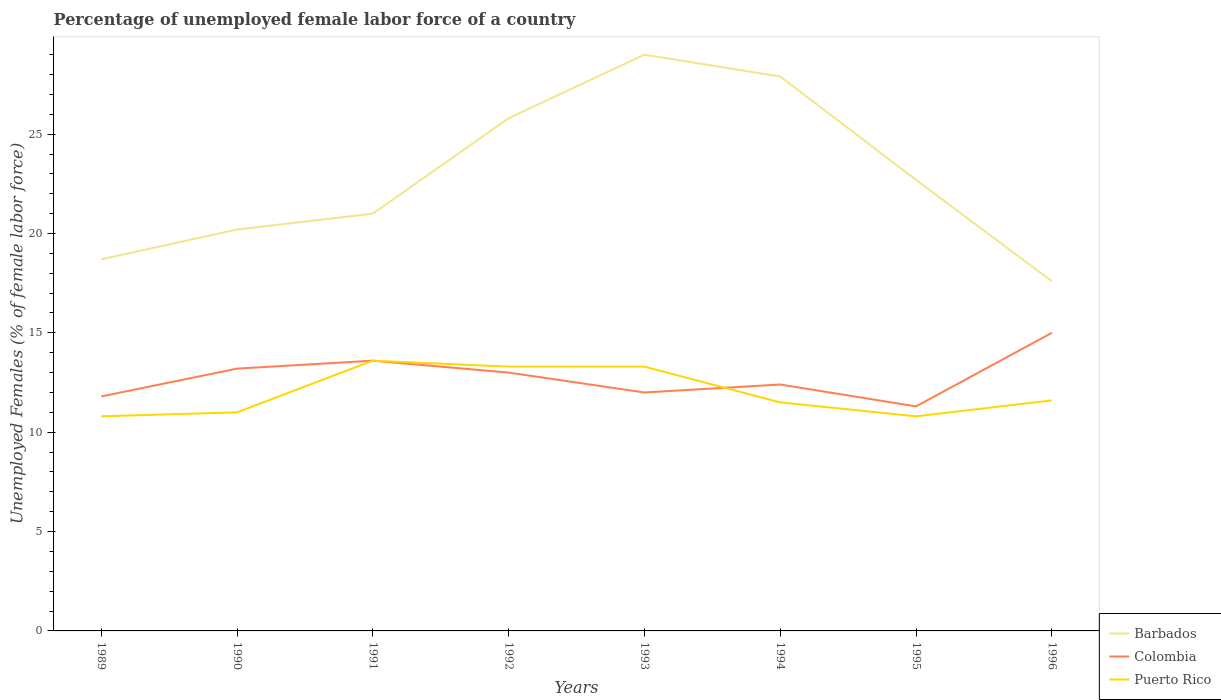How many different coloured lines are there?
Make the answer very short. 3. Is the number of lines equal to the number of legend labels?
Give a very brief answer. Yes. Across all years, what is the maximum percentage of unemployed female labor force in Colombia?
Ensure brevity in your answer.  11.3. In which year was the percentage of unemployed female labor force in Puerto Rico maximum?
Make the answer very short. 1989. What is the total percentage of unemployed female labor force in Colombia in the graph?
Offer a terse response. 0.2. What is the difference between the highest and the second highest percentage of unemployed female labor force in Barbados?
Offer a terse response. 11.4. What is the difference between the highest and the lowest percentage of unemployed female labor force in Colombia?
Offer a very short reply. 4. Is the percentage of unemployed female labor force in Colombia strictly greater than the percentage of unemployed female labor force in Puerto Rico over the years?
Offer a terse response. No. How many lines are there?
Make the answer very short. 3. How many years are there in the graph?
Offer a very short reply. 8. Are the values on the major ticks of Y-axis written in scientific E-notation?
Make the answer very short. No. Does the graph contain any zero values?
Your answer should be compact. No. Does the graph contain grids?
Your answer should be very brief. No. Where does the legend appear in the graph?
Provide a succinct answer. Bottom right. How many legend labels are there?
Ensure brevity in your answer.  3. What is the title of the graph?
Your response must be concise. Percentage of unemployed female labor force of a country. Does "St. Kitts and Nevis" appear as one of the legend labels in the graph?
Offer a terse response. No. What is the label or title of the X-axis?
Offer a terse response. Years. What is the label or title of the Y-axis?
Keep it short and to the point. Unemployed Females (% of female labor force). What is the Unemployed Females (% of female labor force) in Barbados in 1989?
Offer a terse response. 18.7. What is the Unemployed Females (% of female labor force) of Colombia in 1989?
Your answer should be very brief. 11.8. What is the Unemployed Females (% of female labor force) in Puerto Rico in 1989?
Your response must be concise. 10.8. What is the Unemployed Females (% of female labor force) of Barbados in 1990?
Offer a very short reply. 20.2. What is the Unemployed Females (% of female labor force) in Colombia in 1990?
Offer a very short reply. 13.2. What is the Unemployed Females (% of female labor force) of Puerto Rico in 1990?
Your answer should be compact. 11. What is the Unemployed Females (% of female labor force) of Colombia in 1991?
Make the answer very short. 13.6. What is the Unemployed Females (% of female labor force) of Puerto Rico in 1991?
Your answer should be compact. 13.6. What is the Unemployed Females (% of female labor force) in Barbados in 1992?
Offer a terse response. 25.8. What is the Unemployed Females (% of female labor force) in Puerto Rico in 1992?
Provide a succinct answer. 13.3. What is the Unemployed Females (% of female labor force) in Barbados in 1993?
Give a very brief answer. 29. What is the Unemployed Females (% of female labor force) in Puerto Rico in 1993?
Offer a terse response. 13.3. What is the Unemployed Females (% of female labor force) of Barbados in 1994?
Offer a terse response. 27.9. What is the Unemployed Females (% of female labor force) of Colombia in 1994?
Your answer should be compact. 12.4. What is the Unemployed Females (% of female labor force) in Barbados in 1995?
Make the answer very short. 22.7. What is the Unemployed Females (% of female labor force) in Colombia in 1995?
Provide a short and direct response. 11.3. What is the Unemployed Females (% of female labor force) of Puerto Rico in 1995?
Your answer should be compact. 10.8. What is the Unemployed Females (% of female labor force) of Barbados in 1996?
Your answer should be very brief. 17.6. What is the Unemployed Females (% of female labor force) in Colombia in 1996?
Give a very brief answer. 15. What is the Unemployed Females (% of female labor force) of Puerto Rico in 1996?
Provide a succinct answer. 11.6. Across all years, what is the maximum Unemployed Females (% of female labor force) in Colombia?
Offer a very short reply. 15. Across all years, what is the maximum Unemployed Females (% of female labor force) of Puerto Rico?
Keep it short and to the point. 13.6. Across all years, what is the minimum Unemployed Females (% of female labor force) of Barbados?
Provide a succinct answer. 17.6. Across all years, what is the minimum Unemployed Females (% of female labor force) of Colombia?
Make the answer very short. 11.3. Across all years, what is the minimum Unemployed Females (% of female labor force) of Puerto Rico?
Keep it short and to the point. 10.8. What is the total Unemployed Females (% of female labor force) of Barbados in the graph?
Make the answer very short. 182.9. What is the total Unemployed Females (% of female labor force) in Colombia in the graph?
Give a very brief answer. 102.3. What is the total Unemployed Females (% of female labor force) of Puerto Rico in the graph?
Keep it short and to the point. 95.9. What is the difference between the Unemployed Females (% of female labor force) of Colombia in 1989 and that in 1991?
Ensure brevity in your answer.  -1.8. What is the difference between the Unemployed Females (% of female labor force) in Colombia in 1989 and that in 1992?
Ensure brevity in your answer.  -1.2. What is the difference between the Unemployed Females (% of female labor force) of Puerto Rico in 1989 and that in 1992?
Provide a succinct answer. -2.5. What is the difference between the Unemployed Females (% of female labor force) of Puerto Rico in 1989 and that in 1993?
Make the answer very short. -2.5. What is the difference between the Unemployed Females (% of female labor force) of Puerto Rico in 1989 and that in 1994?
Provide a short and direct response. -0.7. What is the difference between the Unemployed Females (% of female labor force) of Barbados in 1989 and that in 1995?
Make the answer very short. -4. What is the difference between the Unemployed Females (% of female labor force) in Puerto Rico in 1989 and that in 1995?
Provide a short and direct response. 0. What is the difference between the Unemployed Females (% of female labor force) in Colombia in 1989 and that in 1996?
Offer a terse response. -3.2. What is the difference between the Unemployed Females (% of female labor force) of Puerto Rico in 1989 and that in 1996?
Ensure brevity in your answer.  -0.8. What is the difference between the Unemployed Females (% of female labor force) in Barbados in 1990 and that in 1991?
Give a very brief answer. -0.8. What is the difference between the Unemployed Females (% of female labor force) of Colombia in 1990 and that in 1991?
Make the answer very short. -0.4. What is the difference between the Unemployed Females (% of female labor force) of Puerto Rico in 1990 and that in 1991?
Your answer should be very brief. -2.6. What is the difference between the Unemployed Females (% of female labor force) of Colombia in 1990 and that in 1992?
Your answer should be compact. 0.2. What is the difference between the Unemployed Females (% of female labor force) of Barbados in 1990 and that in 1993?
Your answer should be very brief. -8.8. What is the difference between the Unemployed Females (% of female labor force) in Puerto Rico in 1990 and that in 1993?
Your response must be concise. -2.3. What is the difference between the Unemployed Females (% of female labor force) in Barbados in 1990 and that in 1994?
Keep it short and to the point. -7.7. What is the difference between the Unemployed Females (% of female labor force) of Colombia in 1990 and that in 1994?
Your response must be concise. 0.8. What is the difference between the Unemployed Females (% of female labor force) of Puerto Rico in 1990 and that in 1994?
Offer a very short reply. -0.5. What is the difference between the Unemployed Females (% of female labor force) of Barbados in 1990 and that in 1995?
Provide a succinct answer. -2.5. What is the difference between the Unemployed Females (% of female labor force) in Colombia in 1990 and that in 1995?
Your response must be concise. 1.9. What is the difference between the Unemployed Females (% of female labor force) in Barbados in 1991 and that in 1992?
Give a very brief answer. -4.8. What is the difference between the Unemployed Females (% of female labor force) in Barbados in 1991 and that in 1993?
Your answer should be compact. -8. What is the difference between the Unemployed Females (% of female labor force) of Colombia in 1991 and that in 1993?
Provide a succinct answer. 1.6. What is the difference between the Unemployed Females (% of female labor force) in Barbados in 1991 and that in 1994?
Keep it short and to the point. -6.9. What is the difference between the Unemployed Females (% of female labor force) of Puerto Rico in 1991 and that in 1994?
Offer a terse response. 2.1. What is the difference between the Unemployed Females (% of female labor force) in Barbados in 1991 and that in 1995?
Offer a very short reply. -1.7. What is the difference between the Unemployed Females (% of female labor force) in Barbados in 1991 and that in 1996?
Offer a terse response. 3.4. What is the difference between the Unemployed Females (% of female labor force) in Colombia in 1991 and that in 1996?
Your response must be concise. -1.4. What is the difference between the Unemployed Females (% of female labor force) of Puerto Rico in 1991 and that in 1996?
Your answer should be compact. 2. What is the difference between the Unemployed Females (% of female labor force) in Colombia in 1992 and that in 1993?
Offer a very short reply. 1. What is the difference between the Unemployed Females (% of female labor force) of Puerto Rico in 1992 and that in 1993?
Make the answer very short. 0. What is the difference between the Unemployed Females (% of female labor force) in Barbados in 1992 and that in 1994?
Your response must be concise. -2.1. What is the difference between the Unemployed Females (% of female labor force) of Puerto Rico in 1992 and that in 1994?
Provide a succinct answer. 1.8. What is the difference between the Unemployed Females (% of female labor force) of Barbados in 1992 and that in 1995?
Keep it short and to the point. 3.1. What is the difference between the Unemployed Females (% of female labor force) of Colombia in 1992 and that in 1995?
Provide a short and direct response. 1.7. What is the difference between the Unemployed Females (% of female labor force) in Colombia in 1992 and that in 1996?
Your response must be concise. -2. What is the difference between the Unemployed Females (% of female labor force) in Barbados in 1993 and that in 1994?
Your response must be concise. 1.1. What is the difference between the Unemployed Females (% of female labor force) in Colombia in 1993 and that in 1994?
Your answer should be compact. -0.4. What is the difference between the Unemployed Females (% of female labor force) in Barbados in 1993 and that in 1995?
Keep it short and to the point. 6.3. What is the difference between the Unemployed Females (% of female labor force) in Colombia in 1993 and that in 1995?
Ensure brevity in your answer.  0.7. What is the difference between the Unemployed Females (% of female labor force) of Barbados in 1993 and that in 1996?
Offer a terse response. 11.4. What is the difference between the Unemployed Females (% of female labor force) in Puerto Rico in 1993 and that in 1996?
Make the answer very short. 1.7. What is the difference between the Unemployed Females (% of female labor force) in Barbados in 1994 and that in 1995?
Ensure brevity in your answer.  5.2. What is the difference between the Unemployed Females (% of female labor force) in Puerto Rico in 1994 and that in 1995?
Your answer should be very brief. 0.7. What is the difference between the Unemployed Females (% of female labor force) in Barbados in 1994 and that in 1996?
Your answer should be very brief. 10.3. What is the difference between the Unemployed Females (% of female labor force) in Colombia in 1994 and that in 1996?
Keep it short and to the point. -2.6. What is the difference between the Unemployed Females (% of female labor force) in Puerto Rico in 1994 and that in 1996?
Ensure brevity in your answer.  -0.1. What is the difference between the Unemployed Females (% of female labor force) in Colombia in 1995 and that in 1996?
Provide a short and direct response. -3.7. What is the difference between the Unemployed Females (% of female labor force) in Colombia in 1989 and the Unemployed Females (% of female labor force) in Puerto Rico in 1990?
Ensure brevity in your answer.  0.8. What is the difference between the Unemployed Females (% of female labor force) in Barbados in 1989 and the Unemployed Females (% of female labor force) in Puerto Rico in 1991?
Give a very brief answer. 5.1. What is the difference between the Unemployed Females (% of female labor force) in Colombia in 1989 and the Unemployed Females (% of female labor force) in Puerto Rico in 1991?
Provide a succinct answer. -1.8. What is the difference between the Unemployed Females (% of female labor force) of Barbados in 1989 and the Unemployed Females (% of female labor force) of Colombia in 1992?
Your answer should be compact. 5.7. What is the difference between the Unemployed Females (% of female labor force) in Barbados in 1989 and the Unemployed Females (% of female labor force) in Puerto Rico in 1992?
Offer a very short reply. 5.4. What is the difference between the Unemployed Females (% of female labor force) in Barbados in 1989 and the Unemployed Females (% of female labor force) in Colombia in 1994?
Your answer should be very brief. 6.3. What is the difference between the Unemployed Females (% of female labor force) of Barbados in 1989 and the Unemployed Females (% of female labor force) of Puerto Rico in 1994?
Offer a terse response. 7.2. What is the difference between the Unemployed Females (% of female labor force) in Barbados in 1990 and the Unemployed Females (% of female labor force) in Puerto Rico in 1991?
Offer a very short reply. 6.6. What is the difference between the Unemployed Females (% of female labor force) in Colombia in 1990 and the Unemployed Females (% of female labor force) in Puerto Rico in 1991?
Keep it short and to the point. -0.4. What is the difference between the Unemployed Females (% of female labor force) of Barbados in 1990 and the Unemployed Females (% of female labor force) of Colombia in 1992?
Offer a terse response. 7.2. What is the difference between the Unemployed Females (% of female labor force) of Barbados in 1990 and the Unemployed Females (% of female labor force) of Puerto Rico in 1992?
Your answer should be compact. 6.9. What is the difference between the Unemployed Females (% of female labor force) in Colombia in 1990 and the Unemployed Females (% of female labor force) in Puerto Rico in 1992?
Provide a succinct answer. -0.1. What is the difference between the Unemployed Females (% of female labor force) in Barbados in 1990 and the Unemployed Females (% of female labor force) in Colombia in 1994?
Ensure brevity in your answer.  7.8. What is the difference between the Unemployed Females (% of female labor force) of Barbados in 1990 and the Unemployed Females (% of female labor force) of Puerto Rico in 1994?
Offer a terse response. 8.7. What is the difference between the Unemployed Females (% of female labor force) of Colombia in 1990 and the Unemployed Females (% of female labor force) of Puerto Rico in 1994?
Provide a succinct answer. 1.7. What is the difference between the Unemployed Females (% of female labor force) in Colombia in 1990 and the Unemployed Females (% of female labor force) in Puerto Rico in 1995?
Provide a short and direct response. 2.4. What is the difference between the Unemployed Females (% of female labor force) in Colombia in 1990 and the Unemployed Females (% of female labor force) in Puerto Rico in 1996?
Ensure brevity in your answer.  1.6. What is the difference between the Unemployed Females (% of female labor force) of Barbados in 1991 and the Unemployed Females (% of female labor force) of Colombia in 1992?
Ensure brevity in your answer.  8. What is the difference between the Unemployed Females (% of female labor force) in Colombia in 1991 and the Unemployed Females (% of female labor force) in Puerto Rico in 1992?
Your answer should be compact. 0.3. What is the difference between the Unemployed Females (% of female labor force) of Colombia in 1991 and the Unemployed Females (% of female labor force) of Puerto Rico in 1993?
Ensure brevity in your answer.  0.3. What is the difference between the Unemployed Females (% of female labor force) in Barbados in 1991 and the Unemployed Females (% of female labor force) in Puerto Rico in 1994?
Give a very brief answer. 9.5. What is the difference between the Unemployed Females (% of female labor force) in Barbados in 1991 and the Unemployed Females (% of female labor force) in Colombia in 1995?
Make the answer very short. 9.7. What is the difference between the Unemployed Females (% of female labor force) of Colombia in 1991 and the Unemployed Females (% of female labor force) of Puerto Rico in 1995?
Make the answer very short. 2.8. What is the difference between the Unemployed Females (% of female labor force) in Barbados in 1991 and the Unemployed Females (% of female labor force) in Puerto Rico in 1996?
Keep it short and to the point. 9.4. What is the difference between the Unemployed Females (% of female labor force) in Colombia in 1991 and the Unemployed Females (% of female labor force) in Puerto Rico in 1996?
Your answer should be compact. 2. What is the difference between the Unemployed Females (% of female labor force) in Barbados in 1992 and the Unemployed Females (% of female labor force) in Puerto Rico in 1993?
Ensure brevity in your answer.  12.5. What is the difference between the Unemployed Females (% of female labor force) in Barbados in 1992 and the Unemployed Females (% of female labor force) in Puerto Rico in 1994?
Make the answer very short. 14.3. What is the difference between the Unemployed Females (% of female labor force) of Colombia in 1992 and the Unemployed Females (% of female labor force) of Puerto Rico in 1994?
Your answer should be compact. 1.5. What is the difference between the Unemployed Females (% of female labor force) in Barbados in 1992 and the Unemployed Females (% of female labor force) in Puerto Rico in 1995?
Your response must be concise. 15. What is the difference between the Unemployed Females (% of female labor force) of Colombia in 1992 and the Unemployed Females (% of female labor force) of Puerto Rico in 1995?
Make the answer very short. 2.2. What is the difference between the Unemployed Females (% of female labor force) of Barbados in 1992 and the Unemployed Females (% of female labor force) of Colombia in 1996?
Your answer should be compact. 10.8. What is the difference between the Unemployed Females (% of female labor force) of Colombia in 1992 and the Unemployed Females (% of female labor force) of Puerto Rico in 1996?
Keep it short and to the point. 1.4. What is the difference between the Unemployed Females (% of female labor force) in Barbados in 1993 and the Unemployed Females (% of female labor force) in Colombia in 1995?
Offer a very short reply. 17.7. What is the difference between the Unemployed Females (% of female labor force) in Colombia in 1993 and the Unemployed Females (% of female labor force) in Puerto Rico in 1995?
Make the answer very short. 1.2. What is the difference between the Unemployed Females (% of female labor force) of Barbados in 1993 and the Unemployed Females (% of female labor force) of Colombia in 1996?
Your answer should be compact. 14. What is the difference between the Unemployed Females (% of female labor force) in Barbados in 1994 and the Unemployed Females (% of female labor force) in Colombia in 1995?
Your answer should be compact. 16.6. What is the difference between the Unemployed Females (% of female labor force) of Barbados in 1994 and the Unemployed Females (% of female labor force) of Colombia in 1996?
Your response must be concise. 12.9. What is the difference between the Unemployed Females (% of female labor force) in Barbados in 1995 and the Unemployed Females (% of female labor force) in Colombia in 1996?
Offer a very short reply. 7.7. What is the average Unemployed Females (% of female labor force) of Barbados per year?
Your answer should be very brief. 22.86. What is the average Unemployed Females (% of female labor force) of Colombia per year?
Ensure brevity in your answer.  12.79. What is the average Unemployed Females (% of female labor force) of Puerto Rico per year?
Give a very brief answer. 11.99. In the year 1991, what is the difference between the Unemployed Females (% of female labor force) in Barbados and Unemployed Females (% of female labor force) in Colombia?
Offer a terse response. 7.4. In the year 1991, what is the difference between the Unemployed Females (% of female labor force) in Colombia and Unemployed Females (% of female labor force) in Puerto Rico?
Make the answer very short. 0. In the year 1992, what is the difference between the Unemployed Females (% of female labor force) in Barbados and Unemployed Females (% of female labor force) in Colombia?
Give a very brief answer. 12.8. In the year 1992, what is the difference between the Unemployed Females (% of female labor force) in Colombia and Unemployed Females (% of female labor force) in Puerto Rico?
Provide a short and direct response. -0.3. In the year 1993, what is the difference between the Unemployed Females (% of female labor force) of Barbados and Unemployed Females (% of female labor force) of Colombia?
Provide a short and direct response. 17. In the year 1994, what is the difference between the Unemployed Females (% of female labor force) of Barbados and Unemployed Females (% of female labor force) of Puerto Rico?
Ensure brevity in your answer.  16.4. In the year 1995, what is the difference between the Unemployed Females (% of female labor force) of Barbados and Unemployed Females (% of female labor force) of Colombia?
Provide a succinct answer. 11.4. In the year 1995, what is the difference between the Unemployed Females (% of female labor force) in Barbados and Unemployed Females (% of female labor force) in Puerto Rico?
Give a very brief answer. 11.9. In the year 1996, what is the difference between the Unemployed Females (% of female labor force) of Barbados and Unemployed Females (% of female labor force) of Colombia?
Offer a very short reply. 2.6. In the year 1996, what is the difference between the Unemployed Females (% of female labor force) in Barbados and Unemployed Females (% of female labor force) in Puerto Rico?
Keep it short and to the point. 6. In the year 1996, what is the difference between the Unemployed Females (% of female labor force) of Colombia and Unemployed Females (% of female labor force) of Puerto Rico?
Keep it short and to the point. 3.4. What is the ratio of the Unemployed Females (% of female labor force) of Barbados in 1989 to that in 1990?
Give a very brief answer. 0.93. What is the ratio of the Unemployed Females (% of female labor force) of Colombia in 1989 to that in 1990?
Offer a terse response. 0.89. What is the ratio of the Unemployed Females (% of female labor force) of Puerto Rico in 1989 to that in 1990?
Offer a very short reply. 0.98. What is the ratio of the Unemployed Females (% of female labor force) in Barbados in 1989 to that in 1991?
Keep it short and to the point. 0.89. What is the ratio of the Unemployed Females (% of female labor force) in Colombia in 1989 to that in 1991?
Offer a very short reply. 0.87. What is the ratio of the Unemployed Females (% of female labor force) of Puerto Rico in 1989 to that in 1991?
Provide a short and direct response. 0.79. What is the ratio of the Unemployed Females (% of female labor force) in Barbados in 1989 to that in 1992?
Offer a terse response. 0.72. What is the ratio of the Unemployed Females (% of female labor force) of Colombia in 1989 to that in 1992?
Make the answer very short. 0.91. What is the ratio of the Unemployed Females (% of female labor force) in Puerto Rico in 1989 to that in 1992?
Provide a short and direct response. 0.81. What is the ratio of the Unemployed Females (% of female labor force) of Barbados in 1989 to that in 1993?
Ensure brevity in your answer.  0.64. What is the ratio of the Unemployed Females (% of female labor force) in Colombia in 1989 to that in 1993?
Give a very brief answer. 0.98. What is the ratio of the Unemployed Females (% of female labor force) in Puerto Rico in 1989 to that in 1993?
Make the answer very short. 0.81. What is the ratio of the Unemployed Females (% of female labor force) of Barbados in 1989 to that in 1994?
Your response must be concise. 0.67. What is the ratio of the Unemployed Females (% of female labor force) in Colombia in 1989 to that in 1994?
Provide a short and direct response. 0.95. What is the ratio of the Unemployed Females (% of female labor force) in Puerto Rico in 1989 to that in 1994?
Your response must be concise. 0.94. What is the ratio of the Unemployed Females (% of female labor force) of Barbados in 1989 to that in 1995?
Provide a succinct answer. 0.82. What is the ratio of the Unemployed Females (% of female labor force) of Colombia in 1989 to that in 1995?
Provide a short and direct response. 1.04. What is the ratio of the Unemployed Females (% of female labor force) in Puerto Rico in 1989 to that in 1995?
Ensure brevity in your answer.  1. What is the ratio of the Unemployed Females (% of female labor force) of Colombia in 1989 to that in 1996?
Give a very brief answer. 0.79. What is the ratio of the Unemployed Females (% of female labor force) of Barbados in 1990 to that in 1991?
Make the answer very short. 0.96. What is the ratio of the Unemployed Females (% of female labor force) in Colombia in 1990 to that in 1991?
Keep it short and to the point. 0.97. What is the ratio of the Unemployed Females (% of female labor force) of Puerto Rico in 1990 to that in 1991?
Make the answer very short. 0.81. What is the ratio of the Unemployed Females (% of female labor force) in Barbados in 1990 to that in 1992?
Provide a short and direct response. 0.78. What is the ratio of the Unemployed Females (% of female labor force) in Colombia in 1990 to that in 1992?
Ensure brevity in your answer.  1.02. What is the ratio of the Unemployed Females (% of female labor force) of Puerto Rico in 1990 to that in 1992?
Offer a terse response. 0.83. What is the ratio of the Unemployed Females (% of female labor force) in Barbados in 1990 to that in 1993?
Keep it short and to the point. 0.7. What is the ratio of the Unemployed Females (% of female labor force) of Puerto Rico in 1990 to that in 1993?
Offer a very short reply. 0.83. What is the ratio of the Unemployed Females (% of female labor force) of Barbados in 1990 to that in 1994?
Make the answer very short. 0.72. What is the ratio of the Unemployed Females (% of female labor force) in Colombia in 1990 to that in 1994?
Give a very brief answer. 1.06. What is the ratio of the Unemployed Females (% of female labor force) of Puerto Rico in 1990 to that in 1994?
Ensure brevity in your answer.  0.96. What is the ratio of the Unemployed Females (% of female labor force) in Barbados in 1990 to that in 1995?
Keep it short and to the point. 0.89. What is the ratio of the Unemployed Females (% of female labor force) of Colombia in 1990 to that in 1995?
Your answer should be compact. 1.17. What is the ratio of the Unemployed Females (% of female labor force) of Puerto Rico in 1990 to that in 1995?
Offer a terse response. 1.02. What is the ratio of the Unemployed Females (% of female labor force) of Barbados in 1990 to that in 1996?
Your answer should be compact. 1.15. What is the ratio of the Unemployed Females (% of female labor force) of Colombia in 1990 to that in 1996?
Your answer should be compact. 0.88. What is the ratio of the Unemployed Females (% of female labor force) in Puerto Rico in 1990 to that in 1996?
Your answer should be compact. 0.95. What is the ratio of the Unemployed Females (% of female labor force) of Barbados in 1991 to that in 1992?
Keep it short and to the point. 0.81. What is the ratio of the Unemployed Females (% of female labor force) of Colombia in 1991 to that in 1992?
Provide a succinct answer. 1.05. What is the ratio of the Unemployed Females (% of female labor force) of Puerto Rico in 1991 to that in 1992?
Provide a short and direct response. 1.02. What is the ratio of the Unemployed Females (% of female labor force) of Barbados in 1991 to that in 1993?
Provide a succinct answer. 0.72. What is the ratio of the Unemployed Females (% of female labor force) in Colombia in 1991 to that in 1993?
Your response must be concise. 1.13. What is the ratio of the Unemployed Females (% of female labor force) in Puerto Rico in 1991 to that in 1993?
Your answer should be very brief. 1.02. What is the ratio of the Unemployed Females (% of female labor force) of Barbados in 1991 to that in 1994?
Offer a terse response. 0.75. What is the ratio of the Unemployed Females (% of female labor force) in Colombia in 1991 to that in 1994?
Provide a succinct answer. 1.1. What is the ratio of the Unemployed Females (% of female labor force) in Puerto Rico in 1991 to that in 1994?
Your response must be concise. 1.18. What is the ratio of the Unemployed Females (% of female labor force) of Barbados in 1991 to that in 1995?
Your answer should be compact. 0.93. What is the ratio of the Unemployed Females (% of female labor force) in Colombia in 1991 to that in 1995?
Offer a terse response. 1.2. What is the ratio of the Unemployed Females (% of female labor force) of Puerto Rico in 1991 to that in 1995?
Provide a succinct answer. 1.26. What is the ratio of the Unemployed Females (% of female labor force) of Barbados in 1991 to that in 1996?
Your response must be concise. 1.19. What is the ratio of the Unemployed Females (% of female labor force) of Colombia in 1991 to that in 1996?
Keep it short and to the point. 0.91. What is the ratio of the Unemployed Females (% of female labor force) of Puerto Rico in 1991 to that in 1996?
Offer a very short reply. 1.17. What is the ratio of the Unemployed Females (% of female labor force) of Barbados in 1992 to that in 1993?
Offer a very short reply. 0.89. What is the ratio of the Unemployed Females (% of female labor force) of Barbados in 1992 to that in 1994?
Provide a short and direct response. 0.92. What is the ratio of the Unemployed Females (% of female labor force) in Colombia in 1992 to that in 1994?
Provide a succinct answer. 1.05. What is the ratio of the Unemployed Females (% of female labor force) of Puerto Rico in 1992 to that in 1994?
Your answer should be very brief. 1.16. What is the ratio of the Unemployed Females (% of female labor force) in Barbados in 1992 to that in 1995?
Your answer should be compact. 1.14. What is the ratio of the Unemployed Females (% of female labor force) of Colombia in 1992 to that in 1995?
Your response must be concise. 1.15. What is the ratio of the Unemployed Females (% of female labor force) of Puerto Rico in 1992 to that in 1995?
Ensure brevity in your answer.  1.23. What is the ratio of the Unemployed Females (% of female labor force) of Barbados in 1992 to that in 1996?
Provide a short and direct response. 1.47. What is the ratio of the Unemployed Females (% of female labor force) of Colombia in 1992 to that in 1996?
Offer a very short reply. 0.87. What is the ratio of the Unemployed Females (% of female labor force) in Puerto Rico in 1992 to that in 1996?
Give a very brief answer. 1.15. What is the ratio of the Unemployed Females (% of female labor force) in Barbados in 1993 to that in 1994?
Provide a short and direct response. 1.04. What is the ratio of the Unemployed Females (% of female labor force) in Colombia in 1993 to that in 1994?
Provide a succinct answer. 0.97. What is the ratio of the Unemployed Females (% of female labor force) of Puerto Rico in 1993 to that in 1994?
Give a very brief answer. 1.16. What is the ratio of the Unemployed Females (% of female labor force) in Barbados in 1993 to that in 1995?
Your response must be concise. 1.28. What is the ratio of the Unemployed Females (% of female labor force) in Colombia in 1993 to that in 1995?
Make the answer very short. 1.06. What is the ratio of the Unemployed Females (% of female labor force) of Puerto Rico in 1993 to that in 1995?
Offer a very short reply. 1.23. What is the ratio of the Unemployed Females (% of female labor force) in Barbados in 1993 to that in 1996?
Offer a terse response. 1.65. What is the ratio of the Unemployed Females (% of female labor force) in Puerto Rico in 1993 to that in 1996?
Your answer should be very brief. 1.15. What is the ratio of the Unemployed Females (% of female labor force) of Barbados in 1994 to that in 1995?
Offer a terse response. 1.23. What is the ratio of the Unemployed Females (% of female labor force) of Colombia in 1994 to that in 1995?
Provide a succinct answer. 1.1. What is the ratio of the Unemployed Females (% of female labor force) of Puerto Rico in 1994 to that in 1995?
Offer a terse response. 1.06. What is the ratio of the Unemployed Females (% of female labor force) of Barbados in 1994 to that in 1996?
Make the answer very short. 1.59. What is the ratio of the Unemployed Females (% of female labor force) in Colombia in 1994 to that in 1996?
Provide a succinct answer. 0.83. What is the ratio of the Unemployed Females (% of female labor force) in Barbados in 1995 to that in 1996?
Provide a short and direct response. 1.29. What is the ratio of the Unemployed Females (% of female labor force) in Colombia in 1995 to that in 1996?
Provide a short and direct response. 0.75. What is the ratio of the Unemployed Females (% of female labor force) of Puerto Rico in 1995 to that in 1996?
Provide a short and direct response. 0.93. What is the difference between the highest and the second highest Unemployed Females (% of female labor force) in Barbados?
Keep it short and to the point. 1.1. What is the difference between the highest and the second highest Unemployed Females (% of female labor force) in Puerto Rico?
Your answer should be very brief. 0.3. What is the difference between the highest and the lowest Unemployed Females (% of female labor force) in Barbados?
Give a very brief answer. 11.4. 